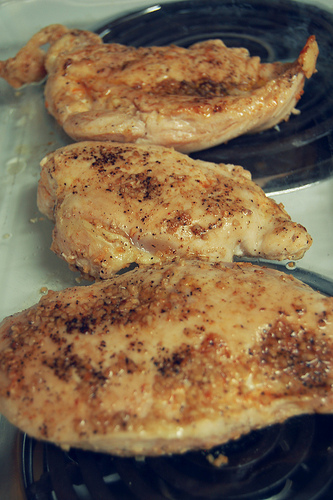<image>
Is the chicken on the burner? Yes. Looking at the image, I can see the chicken is positioned on top of the burner, with the burner providing support. 